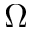Convert formula to latex. <formula><loc_0><loc_0><loc_500><loc_500>\Omega</formula> 